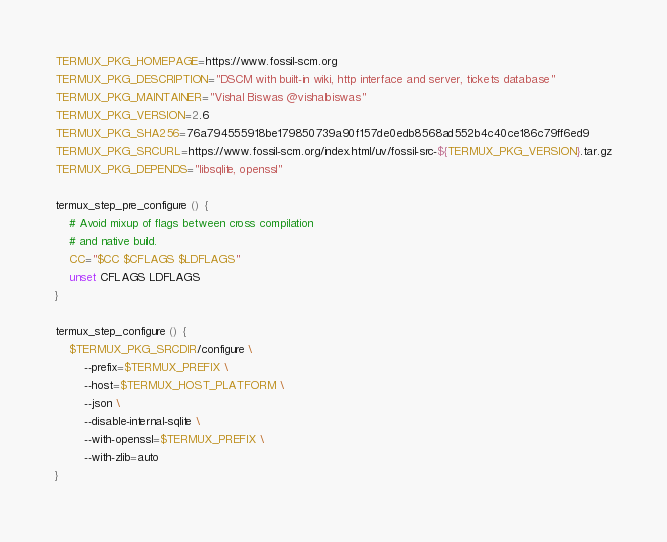<code> <loc_0><loc_0><loc_500><loc_500><_Bash_>TERMUX_PKG_HOMEPAGE=https://www.fossil-scm.org
TERMUX_PKG_DESCRIPTION="DSCM with built-in wiki, http interface and server, tickets database"
TERMUX_PKG_MAINTAINER="Vishal Biswas @vishalbiswas"
TERMUX_PKG_VERSION=2.6
TERMUX_PKG_SHA256=76a794555918be179850739a90f157de0edb8568ad552b4c40ce186c79ff6ed9
TERMUX_PKG_SRCURL=https://www.fossil-scm.org/index.html/uv/fossil-src-${TERMUX_PKG_VERSION}.tar.gz
TERMUX_PKG_DEPENDS="libsqlite, openssl"

termux_step_pre_configure () {
	# Avoid mixup of flags between cross compilation
	# and native build.
	CC="$CC $CFLAGS $LDFLAGS"
	unset CFLAGS LDFLAGS
}

termux_step_configure () {
	$TERMUX_PKG_SRCDIR/configure \
		--prefix=$TERMUX_PREFIX \
		--host=$TERMUX_HOST_PLATFORM \
		--json \
		--disable-internal-sqlite \
		--with-openssl=$TERMUX_PREFIX \
		--with-zlib=auto
}

</code> 